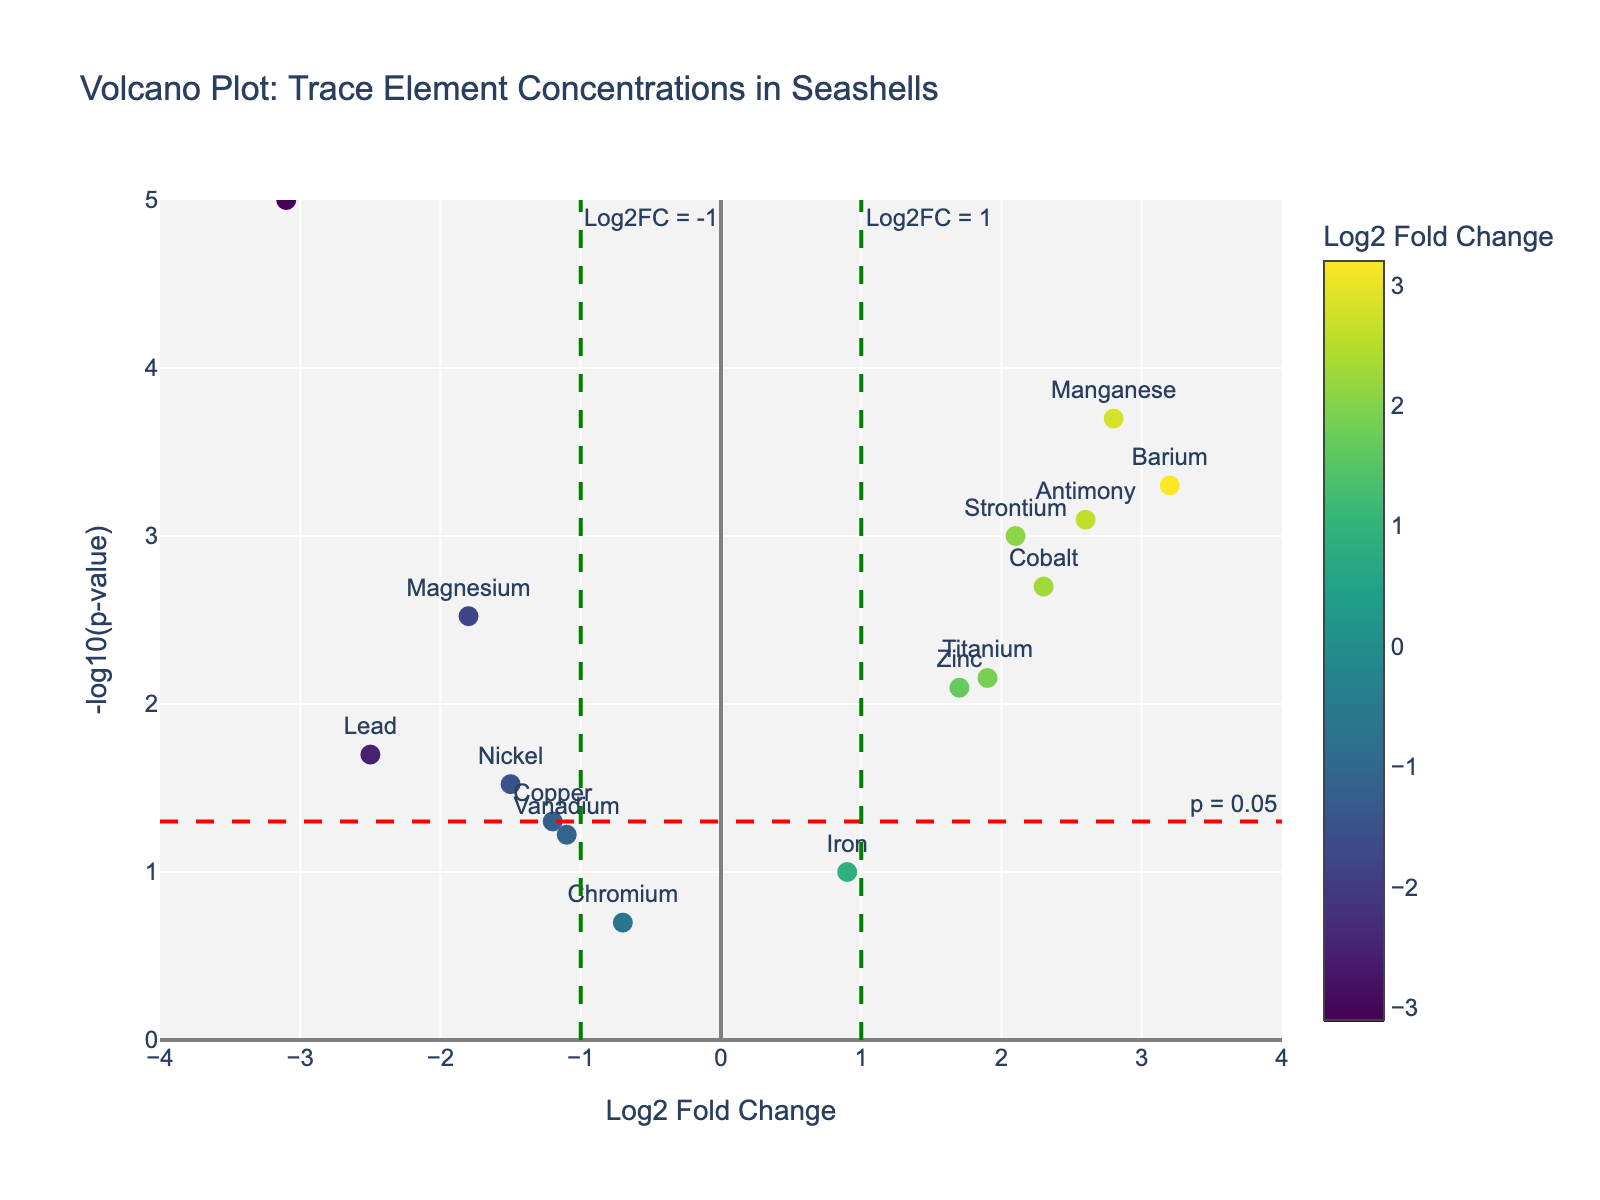What is the title of the plot? The title of the plot is located at the top of the figure. It summarizes the comparison of trace element concentrations in seashells from various coastal regions.
Answer: Volcano Plot: Trace Element Concentrations in Seashells Which element has the highest -log10(p-value)? Look for the element positioned highest on the y-axis representing -log10(p-value).
Answer: Cadmium How many elements have a Log2 Fold Change greater than 1? Count the data points on the right side of the vertical line at Log2 Fold Change = 1.
Answer: 5 Which element has the lowest Log2 Fold Change? The element with the smallest Log2 Fold Change value will be on the leftmost side of the x-axis.
Answer: Cadmium Are there any elements with a p-value less than 0.05 and a Log2 Fold Change between -1 and 1? Check if any elements lie below the horizontal threshold line at p = 0.05 and between the two green vertical lines at Log2FC = -1 and Log2FC = 1.
Answer: Yes, there is one (Iron) Compare the Log2 Fold Changes of Barium and Vanadium. Which is greater? Find the positions of Barium and Vanadium on the x-axis and compare their Log2 Fold Change values.
Answer: Barium Which element is closer to the threshold Log2 Fold Change line at 1: Strontium or Titanium? Compare the horizontal positions of Strontium and Titanium with the vertical line at Log2 Fold Change = 1.
Answer: Titanium What is the -log10(p-value) for Manganese? Find Manganese on the plot and read the corresponding y-axis value.
Answer: 3.70 How many elements have statistically significant p-values (less than 0.05)? Count the elements above the horizontal threshold line at p = 0.05.
Answer: 9 Which element has a Log2 Fold Change closest to zero but is still statistically significant? Find the data points near Log2 Fold Change = 0 and check their positions relative to the horizontal threshold line at p = 0.05.
Answer: Iron 